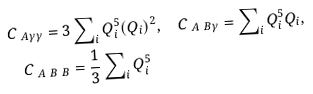<formula> <loc_0><loc_0><loc_500><loc_500>& C _ { \ A \gamma \gamma } = 3 \sum \nolimits _ { i } Q ^ { 5 } _ { i } ( Q _ { i } ) ^ { 2 } , \quad C _ { \ A \ B \gamma } = \sum \nolimits _ { i } Q ^ { 5 } _ { i } Q _ { i } , \\ & \quad C _ { \ A \ B \ B } = \frac { 1 } { 3 } \sum \nolimits _ { i } Q ^ { 5 } _ { i }</formula> 